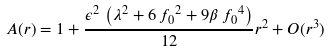<formula> <loc_0><loc_0><loc_500><loc_500>A ( r ) = 1 + \frac { \epsilon ^ { 2 } \, \left ( \lambda ^ { 2 } + 6 \, { f _ { 0 } } ^ { 2 } + 9 \beta \, { f _ { 0 } } ^ { 4 } \right ) } { 1 2 } { r } ^ { 2 } + O ( r ^ { 3 } )</formula> 